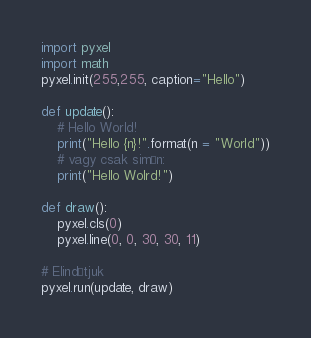<code> <loc_0><loc_0><loc_500><loc_500><_Python_>import pyxel
import math
pyxel.init(255,255, caption="Hello")

def update():
    # Hello World!
	print("Hello {n}!".format(n = "World"))
    # vagy csak simán:
	print("Hello Wolrd!")

def draw():
    pyxel.cls(0)
    pyxel.line(0, 0, 30, 30, 11)
    
# Elindítjuk
pyxel.run(update, draw)</code> 